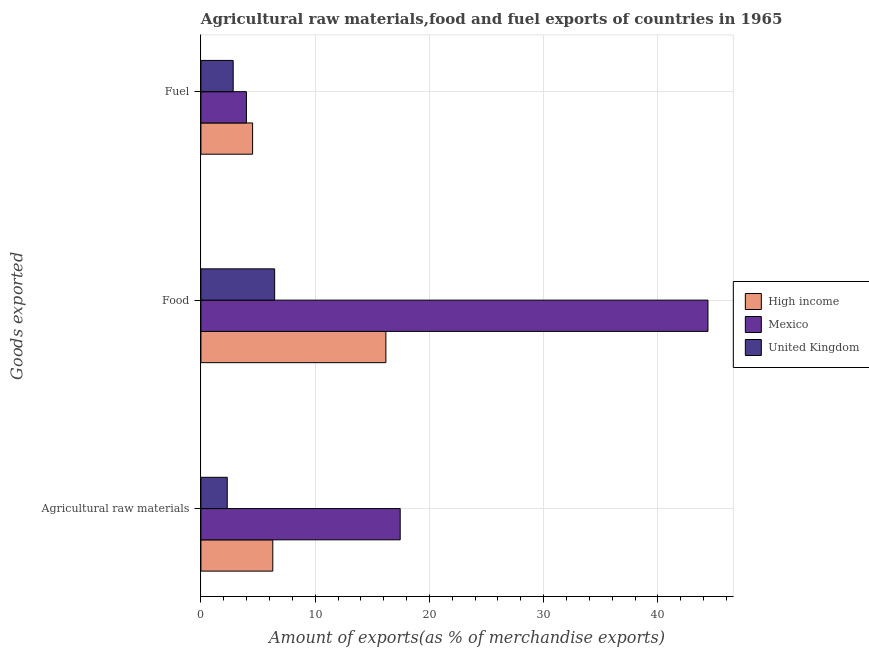How many groups of bars are there?
Provide a short and direct response. 3. How many bars are there on the 1st tick from the top?
Provide a short and direct response. 3. What is the label of the 1st group of bars from the top?
Ensure brevity in your answer.  Fuel. What is the percentage of raw materials exports in High income?
Your answer should be compact. 6.29. Across all countries, what is the maximum percentage of raw materials exports?
Make the answer very short. 17.44. Across all countries, what is the minimum percentage of fuel exports?
Keep it short and to the point. 2.82. In which country was the percentage of fuel exports maximum?
Your answer should be compact. High income. In which country was the percentage of fuel exports minimum?
Your answer should be compact. United Kingdom. What is the total percentage of raw materials exports in the graph?
Offer a terse response. 26.04. What is the difference between the percentage of fuel exports in High income and that in United Kingdom?
Offer a very short reply. 1.7. What is the difference between the percentage of fuel exports in High income and the percentage of food exports in Mexico?
Offer a very short reply. -39.86. What is the average percentage of raw materials exports per country?
Your answer should be very brief. 8.68. What is the difference between the percentage of raw materials exports and percentage of fuel exports in Mexico?
Provide a short and direct response. 13.46. In how many countries, is the percentage of fuel exports greater than 16 %?
Your response must be concise. 0. What is the ratio of the percentage of food exports in High income to that in Mexico?
Provide a succinct answer. 0.36. Is the difference between the percentage of raw materials exports in High income and United Kingdom greater than the difference between the percentage of food exports in High income and United Kingdom?
Make the answer very short. No. What is the difference between the highest and the second highest percentage of food exports?
Keep it short and to the point. 28.2. What is the difference between the highest and the lowest percentage of raw materials exports?
Ensure brevity in your answer.  15.14. In how many countries, is the percentage of fuel exports greater than the average percentage of fuel exports taken over all countries?
Your response must be concise. 2. Is the sum of the percentage of food exports in United Kingdom and Mexico greater than the maximum percentage of fuel exports across all countries?
Provide a short and direct response. Yes. What does the 3rd bar from the top in Fuel represents?
Provide a short and direct response. High income. What does the 3rd bar from the bottom in Fuel represents?
Your answer should be very brief. United Kingdom. How many bars are there?
Provide a short and direct response. 9. Are all the bars in the graph horizontal?
Provide a succinct answer. Yes. How many countries are there in the graph?
Your response must be concise. 3. Are the values on the major ticks of X-axis written in scientific E-notation?
Keep it short and to the point. No. How many legend labels are there?
Your answer should be very brief. 3. How are the legend labels stacked?
Your answer should be compact. Vertical. What is the title of the graph?
Make the answer very short. Agricultural raw materials,food and fuel exports of countries in 1965. What is the label or title of the X-axis?
Your answer should be compact. Amount of exports(as % of merchandise exports). What is the label or title of the Y-axis?
Offer a terse response. Goods exported. What is the Amount of exports(as % of merchandise exports) of High income in Agricultural raw materials?
Offer a very short reply. 6.29. What is the Amount of exports(as % of merchandise exports) in Mexico in Agricultural raw materials?
Provide a short and direct response. 17.44. What is the Amount of exports(as % of merchandise exports) in United Kingdom in Agricultural raw materials?
Offer a very short reply. 2.3. What is the Amount of exports(as % of merchandise exports) in High income in Food?
Offer a very short reply. 16.19. What is the Amount of exports(as % of merchandise exports) in Mexico in Food?
Give a very brief answer. 44.39. What is the Amount of exports(as % of merchandise exports) in United Kingdom in Food?
Give a very brief answer. 6.45. What is the Amount of exports(as % of merchandise exports) of High income in Fuel?
Ensure brevity in your answer.  4.53. What is the Amount of exports(as % of merchandise exports) in Mexico in Fuel?
Ensure brevity in your answer.  3.99. What is the Amount of exports(as % of merchandise exports) of United Kingdom in Fuel?
Provide a short and direct response. 2.82. Across all Goods exported, what is the maximum Amount of exports(as % of merchandise exports) in High income?
Your answer should be very brief. 16.19. Across all Goods exported, what is the maximum Amount of exports(as % of merchandise exports) in Mexico?
Ensure brevity in your answer.  44.39. Across all Goods exported, what is the maximum Amount of exports(as % of merchandise exports) of United Kingdom?
Make the answer very short. 6.45. Across all Goods exported, what is the minimum Amount of exports(as % of merchandise exports) of High income?
Provide a short and direct response. 4.53. Across all Goods exported, what is the minimum Amount of exports(as % of merchandise exports) of Mexico?
Offer a terse response. 3.99. Across all Goods exported, what is the minimum Amount of exports(as % of merchandise exports) of United Kingdom?
Ensure brevity in your answer.  2.3. What is the total Amount of exports(as % of merchandise exports) of High income in the graph?
Make the answer very short. 27.01. What is the total Amount of exports(as % of merchandise exports) in Mexico in the graph?
Offer a very short reply. 65.82. What is the total Amount of exports(as % of merchandise exports) of United Kingdom in the graph?
Your answer should be compact. 11.58. What is the difference between the Amount of exports(as % of merchandise exports) of High income in Agricultural raw materials and that in Food?
Your answer should be very brief. -9.9. What is the difference between the Amount of exports(as % of merchandise exports) of Mexico in Agricultural raw materials and that in Food?
Provide a short and direct response. -26.94. What is the difference between the Amount of exports(as % of merchandise exports) in United Kingdom in Agricultural raw materials and that in Food?
Ensure brevity in your answer.  -4.15. What is the difference between the Amount of exports(as % of merchandise exports) of High income in Agricultural raw materials and that in Fuel?
Your answer should be compact. 1.77. What is the difference between the Amount of exports(as % of merchandise exports) of Mexico in Agricultural raw materials and that in Fuel?
Offer a very short reply. 13.46. What is the difference between the Amount of exports(as % of merchandise exports) of United Kingdom in Agricultural raw materials and that in Fuel?
Your response must be concise. -0.52. What is the difference between the Amount of exports(as % of merchandise exports) of High income in Food and that in Fuel?
Provide a short and direct response. 11.67. What is the difference between the Amount of exports(as % of merchandise exports) of Mexico in Food and that in Fuel?
Offer a terse response. 40.4. What is the difference between the Amount of exports(as % of merchandise exports) of United Kingdom in Food and that in Fuel?
Provide a short and direct response. 3.63. What is the difference between the Amount of exports(as % of merchandise exports) in High income in Agricultural raw materials and the Amount of exports(as % of merchandise exports) in Mexico in Food?
Provide a succinct answer. -38.09. What is the difference between the Amount of exports(as % of merchandise exports) in High income in Agricultural raw materials and the Amount of exports(as % of merchandise exports) in United Kingdom in Food?
Offer a terse response. -0.16. What is the difference between the Amount of exports(as % of merchandise exports) in Mexico in Agricultural raw materials and the Amount of exports(as % of merchandise exports) in United Kingdom in Food?
Offer a terse response. 10.99. What is the difference between the Amount of exports(as % of merchandise exports) in High income in Agricultural raw materials and the Amount of exports(as % of merchandise exports) in Mexico in Fuel?
Offer a terse response. 2.31. What is the difference between the Amount of exports(as % of merchandise exports) of High income in Agricultural raw materials and the Amount of exports(as % of merchandise exports) of United Kingdom in Fuel?
Ensure brevity in your answer.  3.47. What is the difference between the Amount of exports(as % of merchandise exports) of Mexico in Agricultural raw materials and the Amount of exports(as % of merchandise exports) of United Kingdom in Fuel?
Make the answer very short. 14.62. What is the difference between the Amount of exports(as % of merchandise exports) in High income in Food and the Amount of exports(as % of merchandise exports) in Mexico in Fuel?
Your response must be concise. 12.21. What is the difference between the Amount of exports(as % of merchandise exports) in High income in Food and the Amount of exports(as % of merchandise exports) in United Kingdom in Fuel?
Give a very brief answer. 13.37. What is the difference between the Amount of exports(as % of merchandise exports) in Mexico in Food and the Amount of exports(as % of merchandise exports) in United Kingdom in Fuel?
Your answer should be very brief. 41.56. What is the average Amount of exports(as % of merchandise exports) in High income per Goods exported?
Your answer should be very brief. 9. What is the average Amount of exports(as % of merchandise exports) of Mexico per Goods exported?
Offer a terse response. 21.94. What is the average Amount of exports(as % of merchandise exports) in United Kingdom per Goods exported?
Your response must be concise. 3.86. What is the difference between the Amount of exports(as % of merchandise exports) of High income and Amount of exports(as % of merchandise exports) of Mexico in Agricultural raw materials?
Provide a succinct answer. -11.15. What is the difference between the Amount of exports(as % of merchandise exports) of High income and Amount of exports(as % of merchandise exports) of United Kingdom in Agricultural raw materials?
Ensure brevity in your answer.  3.99. What is the difference between the Amount of exports(as % of merchandise exports) in Mexico and Amount of exports(as % of merchandise exports) in United Kingdom in Agricultural raw materials?
Provide a short and direct response. 15.14. What is the difference between the Amount of exports(as % of merchandise exports) of High income and Amount of exports(as % of merchandise exports) of Mexico in Food?
Provide a succinct answer. -28.2. What is the difference between the Amount of exports(as % of merchandise exports) in High income and Amount of exports(as % of merchandise exports) in United Kingdom in Food?
Ensure brevity in your answer.  9.74. What is the difference between the Amount of exports(as % of merchandise exports) of Mexico and Amount of exports(as % of merchandise exports) of United Kingdom in Food?
Provide a succinct answer. 37.93. What is the difference between the Amount of exports(as % of merchandise exports) of High income and Amount of exports(as % of merchandise exports) of Mexico in Fuel?
Offer a very short reply. 0.54. What is the difference between the Amount of exports(as % of merchandise exports) of High income and Amount of exports(as % of merchandise exports) of United Kingdom in Fuel?
Provide a succinct answer. 1.7. What is the difference between the Amount of exports(as % of merchandise exports) of Mexico and Amount of exports(as % of merchandise exports) of United Kingdom in Fuel?
Ensure brevity in your answer.  1.16. What is the ratio of the Amount of exports(as % of merchandise exports) in High income in Agricultural raw materials to that in Food?
Provide a short and direct response. 0.39. What is the ratio of the Amount of exports(as % of merchandise exports) of Mexico in Agricultural raw materials to that in Food?
Provide a succinct answer. 0.39. What is the ratio of the Amount of exports(as % of merchandise exports) of United Kingdom in Agricultural raw materials to that in Food?
Ensure brevity in your answer.  0.36. What is the ratio of the Amount of exports(as % of merchandise exports) of High income in Agricultural raw materials to that in Fuel?
Provide a short and direct response. 1.39. What is the ratio of the Amount of exports(as % of merchandise exports) in Mexico in Agricultural raw materials to that in Fuel?
Ensure brevity in your answer.  4.38. What is the ratio of the Amount of exports(as % of merchandise exports) in United Kingdom in Agricultural raw materials to that in Fuel?
Offer a very short reply. 0.82. What is the ratio of the Amount of exports(as % of merchandise exports) in High income in Food to that in Fuel?
Your answer should be compact. 3.58. What is the ratio of the Amount of exports(as % of merchandise exports) in Mexico in Food to that in Fuel?
Your response must be concise. 11.14. What is the ratio of the Amount of exports(as % of merchandise exports) of United Kingdom in Food to that in Fuel?
Offer a very short reply. 2.29. What is the difference between the highest and the second highest Amount of exports(as % of merchandise exports) of High income?
Your answer should be compact. 9.9. What is the difference between the highest and the second highest Amount of exports(as % of merchandise exports) of Mexico?
Provide a succinct answer. 26.94. What is the difference between the highest and the second highest Amount of exports(as % of merchandise exports) in United Kingdom?
Your response must be concise. 3.63. What is the difference between the highest and the lowest Amount of exports(as % of merchandise exports) of High income?
Keep it short and to the point. 11.67. What is the difference between the highest and the lowest Amount of exports(as % of merchandise exports) in Mexico?
Keep it short and to the point. 40.4. What is the difference between the highest and the lowest Amount of exports(as % of merchandise exports) of United Kingdom?
Keep it short and to the point. 4.15. 